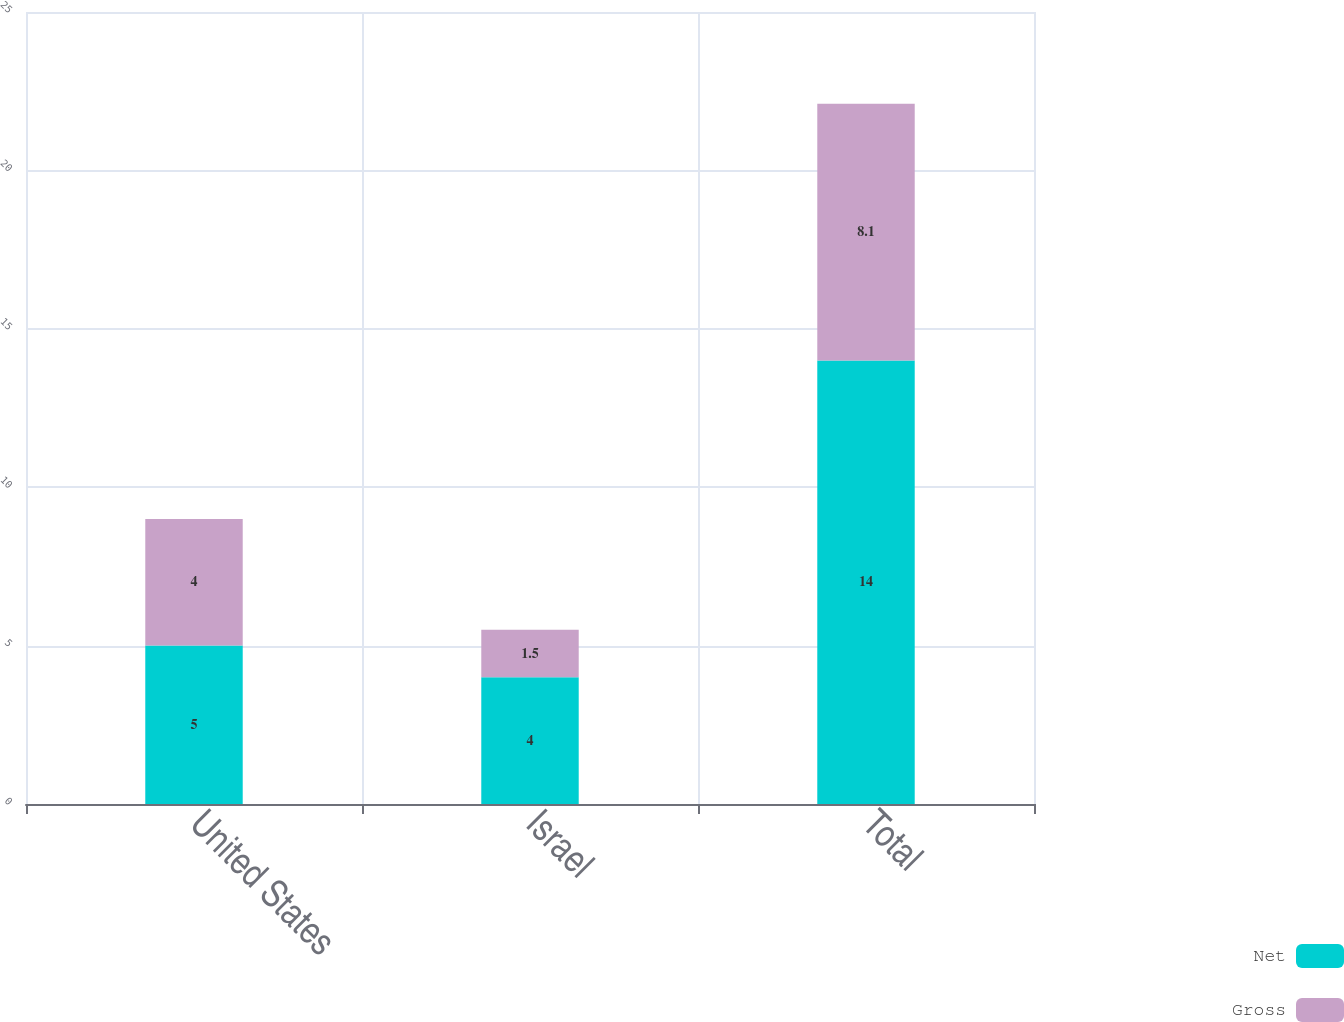Convert chart. <chart><loc_0><loc_0><loc_500><loc_500><stacked_bar_chart><ecel><fcel>United States<fcel>Israel<fcel>Total<nl><fcel>Net<fcel>5<fcel>4<fcel>14<nl><fcel>Gross<fcel>4<fcel>1.5<fcel>8.1<nl></chart> 